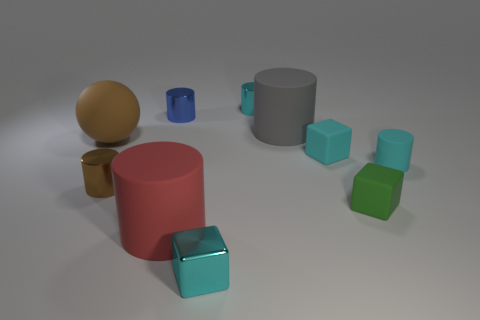Is there a rubber cylinder that has the same size as the gray matte object?
Make the answer very short. Yes. There is a cyan object that is behind the large rubber cylinder that is right of the tiny cyan metal block; is there a red rubber cylinder that is behind it?
Provide a short and direct response. No. There is a big rubber sphere; is it the same color as the big cylinder right of the cyan metal cylinder?
Offer a terse response. No. The cyan block right of the metallic object that is in front of the large object in front of the big matte sphere is made of what material?
Provide a short and direct response. Rubber. The cyan thing in front of the tiny green rubber block has what shape?
Ensure brevity in your answer.  Cube. What size is the cyan block that is made of the same material as the big ball?
Make the answer very short. Small. What number of other tiny things have the same shape as the gray matte object?
Offer a terse response. 4. There is a big rubber cylinder that is behind the small brown metallic object; does it have the same color as the large matte ball?
Your answer should be very brief. No. What number of brown cylinders are behind the tiny cube left of the tiny cyan metallic object that is behind the small blue metallic cylinder?
Offer a very short reply. 1. What number of cyan blocks are both on the right side of the metal cube and in front of the small green matte cube?
Your answer should be very brief. 0. 